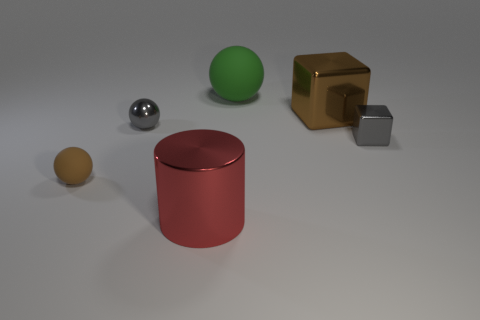There is a big metallic object that is the same color as the tiny rubber ball; what is its shape?
Your answer should be very brief. Cube. There is another metal object that is the same shape as the green thing; what size is it?
Ensure brevity in your answer.  Small. Do the big brown thing and the brown matte thing have the same shape?
Provide a succinct answer. No. There is a metallic object that is on the left side of the cylinder that is left of the green rubber object; are there any large brown metal things in front of it?
Your answer should be very brief. No. What number of large metallic things are the same color as the tiny metal block?
Offer a terse response. 0. There is a metallic thing that is the same size as the shiny sphere; what shape is it?
Your answer should be very brief. Cube. There is a large green rubber sphere; are there any tiny brown things behind it?
Give a very brief answer. No. Do the brown matte thing and the brown metal object have the same size?
Your response must be concise. No. There is a big shiny object that is in front of the brown cube; what shape is it?
Your answer should be compact. Cylinder. Is there a gray metallic thing of the same size as the shiny cylinder?
Make the answer very short. No. 